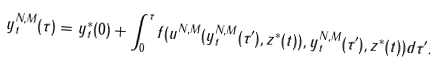Convert formula to latex. <formula><loc_0><loc_0><loc_500><loc_500>y ^ { N , M } _ { t } ( \tau ) = y ^ { * } _ { t } ( 0 ) + \int _ { 0 } ^ { \tau } f ( u ^ { N , M } ( y ^ { N , M } _ { t } ( \tau ^ { \prime } ) , z ^ { * } ( t ) ) , y ^ { N , M } _ { t } ( \tau ^ { \prime } ) , z ^ { * } ( t ) ) d \tau ^ { \prime } .</formula> 